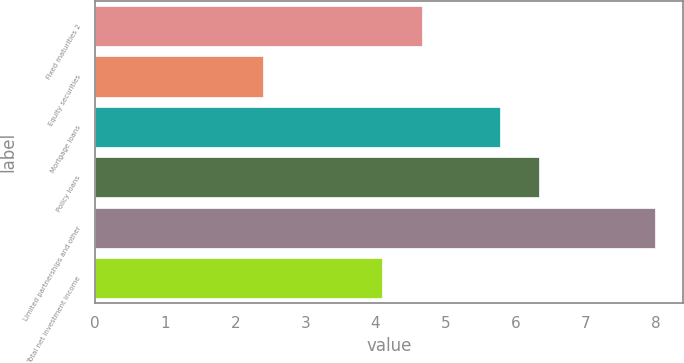<chart> <loc_0><loc_0><loc_500><loc_500><bar_chart><fcel>Fixed maturities 2<fcel>Equity securities<fcel>Mortgage loans<fcel>Policy loans<fcel>Limited partnerships and other<fcel>Total net investment income<nl><fcel>4.66<fcel>2.4<fcel>5.78<fcel>6.34<fcel>8<fcel>4.1<nl></chart> 